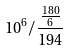Convert formula to latex. <formula><loc_0><loc_0><loc_500><loc_500>1 0 ^ { 6 } / \frac { \frac { 1 8 0 } { 6 } } { 1 9 4 }</formula> 